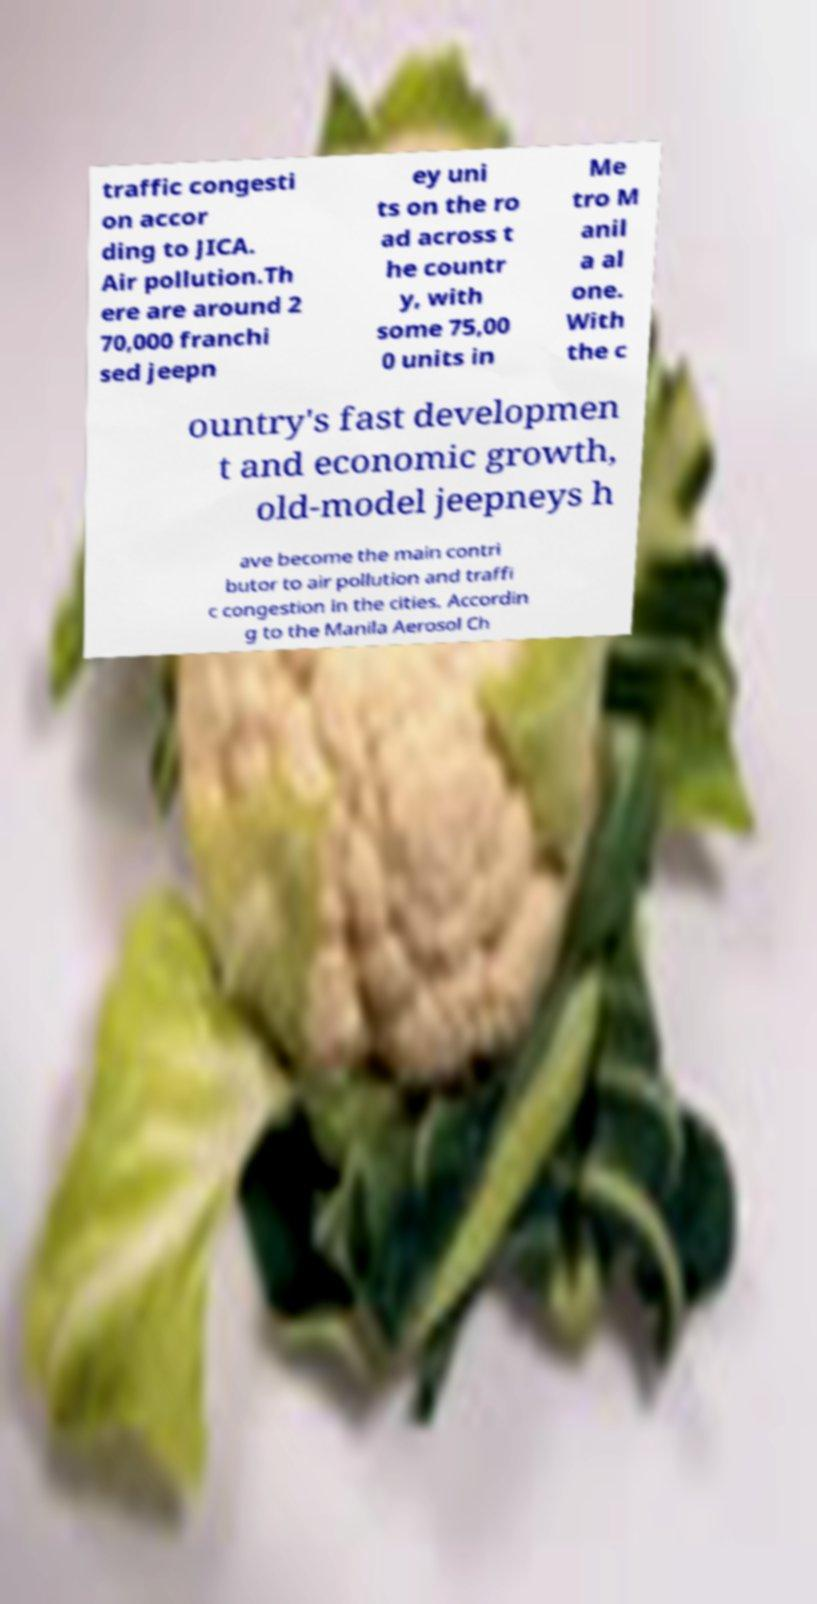Please read and relay the text visible in this image. What does it say? traffic congesti on accor ding to JICA. Air pollution.Th ere are around 2 70,000 franchi sed jeepn ey uni ts on the ro ad across t he countr y, with some 75,00 0 units in Me tro M anil a al one. With the c ountry's fast developmen t and economic growth, old-model jeepneys h ave become the main contri butor to air pollution and traffi c congestion in the cities. Accordin g to the Manila Aerosol Ch 